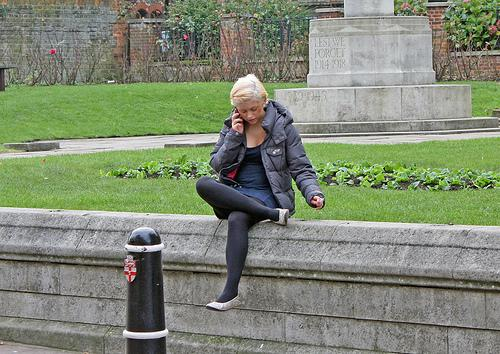Analyze the object coming into contact with the woman and provide a short explanation. The woman is sitting on a short concrete wall, suggesting that she is taking a break or resting while talking on her phone. What sentiment can be inferred from the image? The image suggests a relaxed and peaceful sentiment as the woman engages in her phone conversation amid her peaceful surroundings. Identify the colors of the woman's clothing items in the image. The woman is wearing a gray jacket, a black shirt, blue skirt, and black stockings. Explain the context of the interaction between the woman and her surroundings. The woman is sitting near a grassy area with shrubs and a statue while talking on the phone, possibly enjoying a leisurely outdoor activity. How can you describe the overall quality of the image, considering its details and clarity? The image is of high quality, as it captures specific details of the subject and her surroundings, such as the woman's clothing, her hair color, and clear background features. What is the color of the woman's skirt and shoes in the image? The woman's skirt is blue and her shoes are light grey. How many red objects are there in the image? There are 2 red objects: the red cross on the pole and the small red flowers. Identify three objects found in the background of the image. A concrete statue, brick columns, and a plant bed are in the background. Choose the main object in the image, and list three of its attributes. The main object is the woman, and her attributes include blonde hair, a gray jacket, and black stockings. Provide a brief description of the image focusing on the central figure. A woman with blonde hair is talking on the phone, wearing a grey jacket, black shirt, blue skirt, and black stockings, while sitting on a wall ledge. Is the woman talking on a red phone? The image only points out that the woman is talking on a phone, but the color of the phone is not mentioned. Is the woman wearing high heels? The image states that the woman is wearing white flats, not high heels. Are there any yellow flowers in the plant bed behind the girl? The image only mentions small red flowers, not yellow flowers. Is there a dog sitting beside the woman? The image has no mention of a dog anywhere near the woman. Is there a white fence around the green grassy lawn? The image does not mention any fence surrounding the green grassy lawn. Does the woman have brown hair? The image states that the woman's hair is blonde, not brown. 